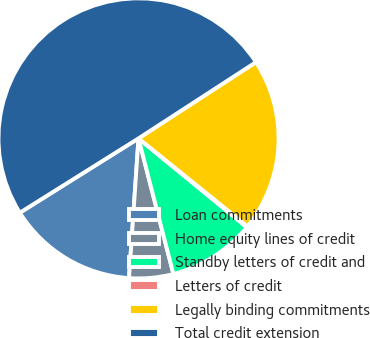Convert chart to OTSL. <chart><loc_0><loc_0><loc_500><loc_500><pie_chart><fcel>Loan commitments<fcel>Home equity lines of credit<fcel>Standby letters of credit and<fcel>Letters of credit<fcel>Legally binding commitments<fcel>Total credit extension<nl><fcel>15.01%<fcel>5.09%<fcel>10.05%<fcel>0.13%<fcel>19.97%<fcel>49.74%<nl></chart> 